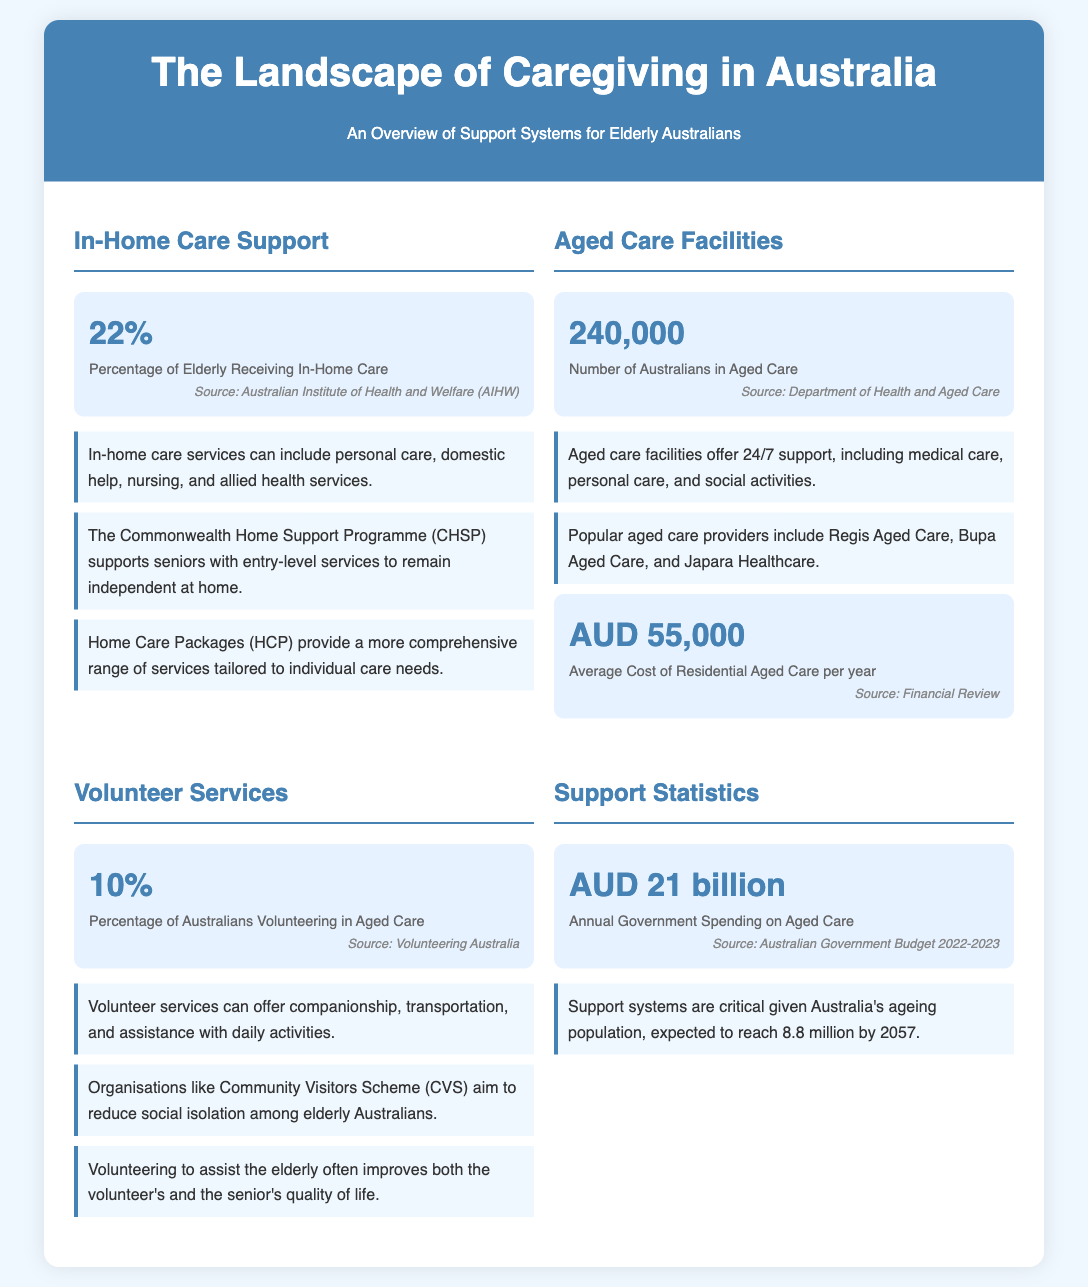What percentage of elderly Australians receive in-home care? This number is directly provided in the section about in-home care support.
Answer: 22% How many Australians are in aged care facilities? The document states the total number of Australians receiving aged care in the aged care facilities section.
Answer: 240,000 What is the average cost of residential aged care per year? This figure is mentioned in the aged care facilities section of the document.
Answer: AUD 55,000 What is the annual government spending on aged care? This statistic can be found in the support statistics section of the infographic.
Answer: AUD 21 billion What percentage of Australians volunteer in aged care? This percentage is specified in the volunteer services section.
Answer: 10% What is the main purpose of the Commonwealth Home Support Programme? The document mentions its aim to support seniors with specific services, highlighting its core purpose.
Answer: To remain independent at home Which organisation aims to reduce social isolation among elderly Australians? This information is contained in the volunteer services section of the document.
Answer: Community Visitors Scheme (CVS) What kind of services does in-home care include? The fact section in the in-home care part outlines the types of care provided.
Answer: Personal care, domestic help, nursing, and allied health services 